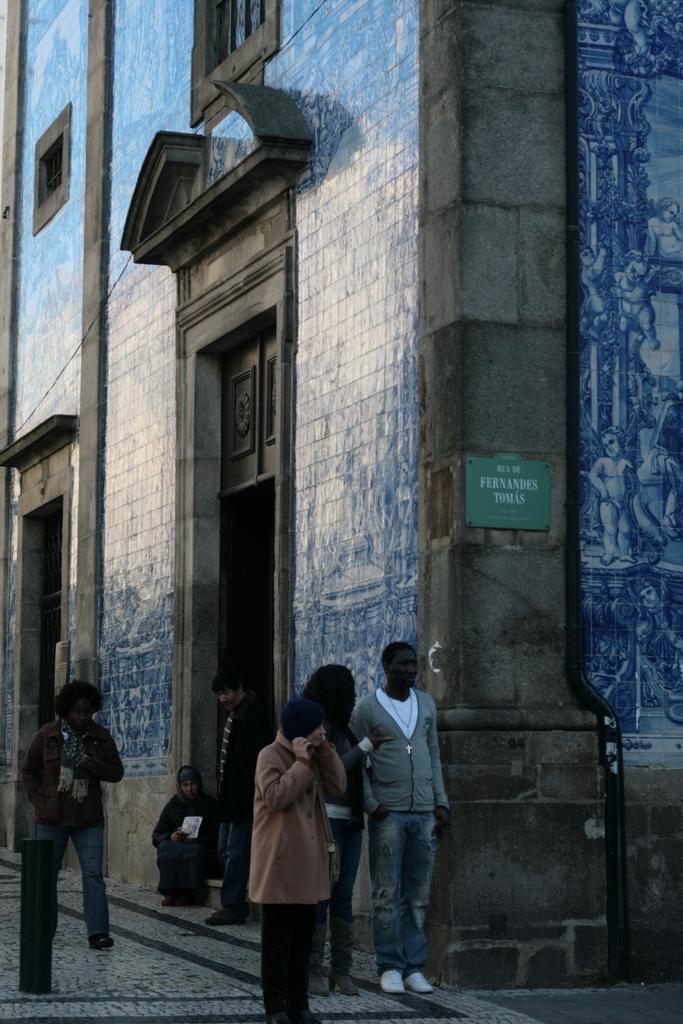How would you summarize this image in a sentence or two? As we can see in the image there are buildings, door and few people here and there. 